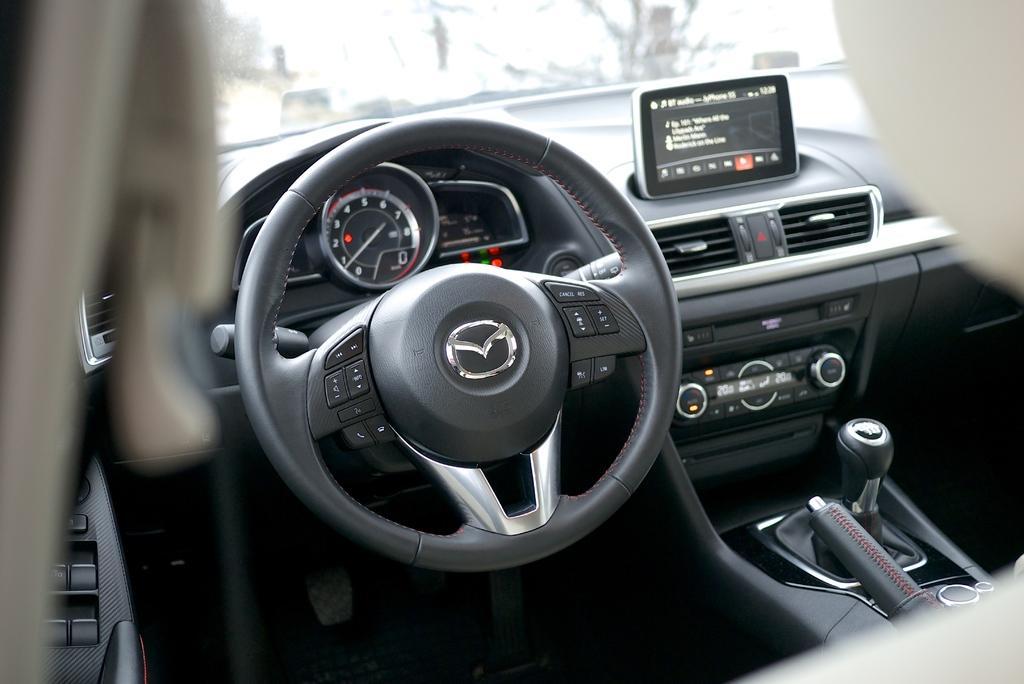Can you describe this image briefly? The picture is captured from inside a car,there is steering,gear rod,speedometer and many other parts of the car are visible in the picture. 